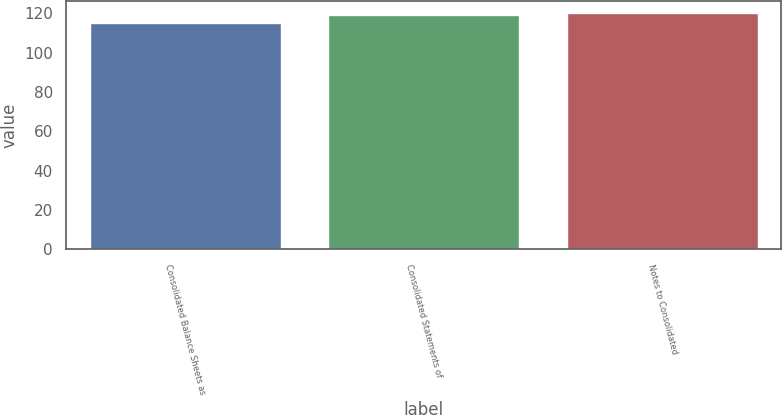Convert chart to OTSL. <chart><loc_0><loc_0><loc_500><loc_500><bar_chart><fcel>Consolidated Balance Sheets as<fcel>Consolidated Statements of<fcel>Notes to Consolidated<nl><fcel>115<fcel>119<fcel>120<nl></chart> 